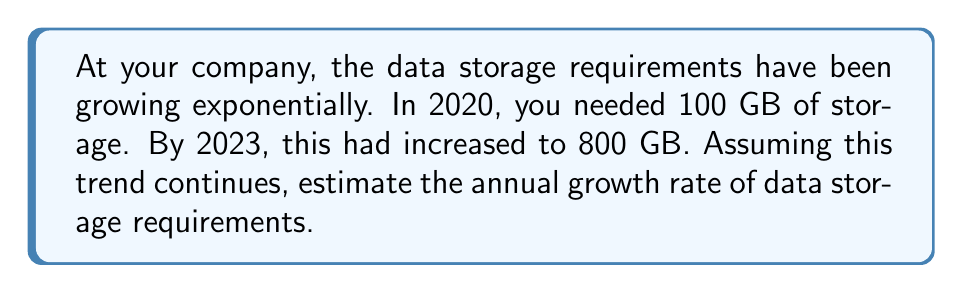Teach me how to tackle this problem. Let's approach this step-by-step:

1) The exponential growth formula is:
   $A = P(1 + r)^t$
   Where A is the final amount, P is the initial amount, r is the growth rate, and t is the time period.

2) We know:
   P = 100 GB (initial storage in 2020)
   A = 800 GB (final storage in 2023)
   t = 3 years (from 2020 to 2023)

3) Let's plug these into our formula:
   $800 = 100(1 + r)^3$

4) Divide both sides by 100:
   $8 = (1 + r)^3$

5) Take the cube root of both sides:
   $\sqrt[3]{8} = 1 + r$

6) Simplify:
   $2 = 1 + r$

7) Subtract 1 from both sides:
   $r = 1$

8) Convert to a percentage:
   $r = 100\%$

Therefore, the estimated annual growth rate is 100% or 1.
Answer: 100% 